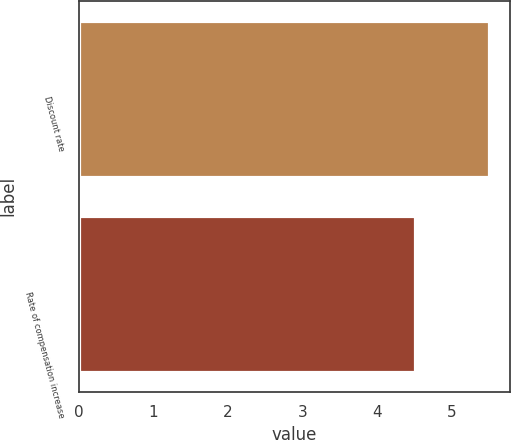Convert chart to OTSL. <chart><loc_0><loc_0><loc_500><loc_500><bar_chart><fcel>Discount rate<fcel>Rate of compensation increase<nl><fcel>5.5<fcel>4.5<nl></chart> 